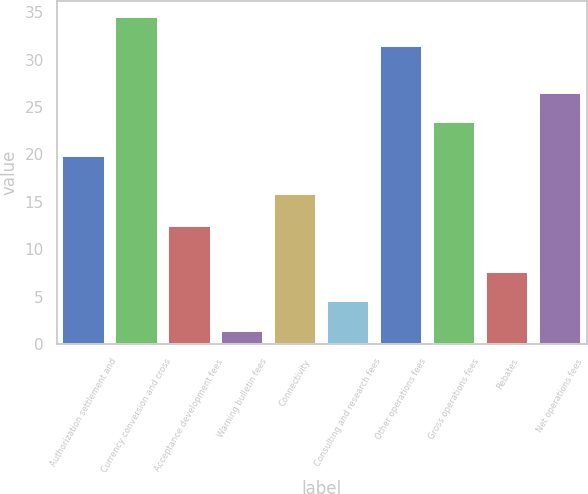Convert chart to OTSL. <chart><loc_0><loc_0><loc_500><loc_500><bar_chart><fcel>Authorization settlement and<fcel>Currency conversion and cross<fcel>Acceptance development fees<fcel>Warning bulletin fees<fcel>Connectivity<fcel>Consulting and research fees<fcel>Other operations fees<fcel>Gross operations fees<fcel>Rebates<fcel>Net operations fees<nl><fcel>19.8<fcel>34.49<fcel>12.5<fcel>1.4<fcel>15.8<fcel>4.5<fcel>31.4<fcel>23.4<fcel>7.59<fcel>26.49<nl></chart> 